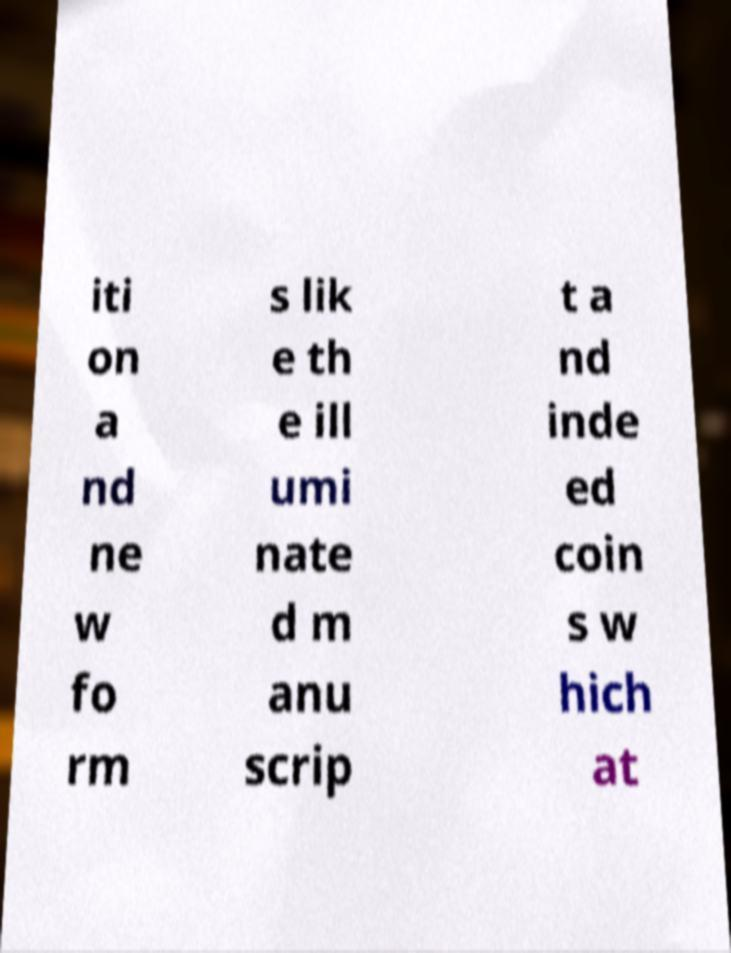I need the written content from this picture converted into text. Can you do that? iti on a nd ne w fo rm s lik e th e ill umi nate d m anu scrip t a nd inde ed coin s w hich at 